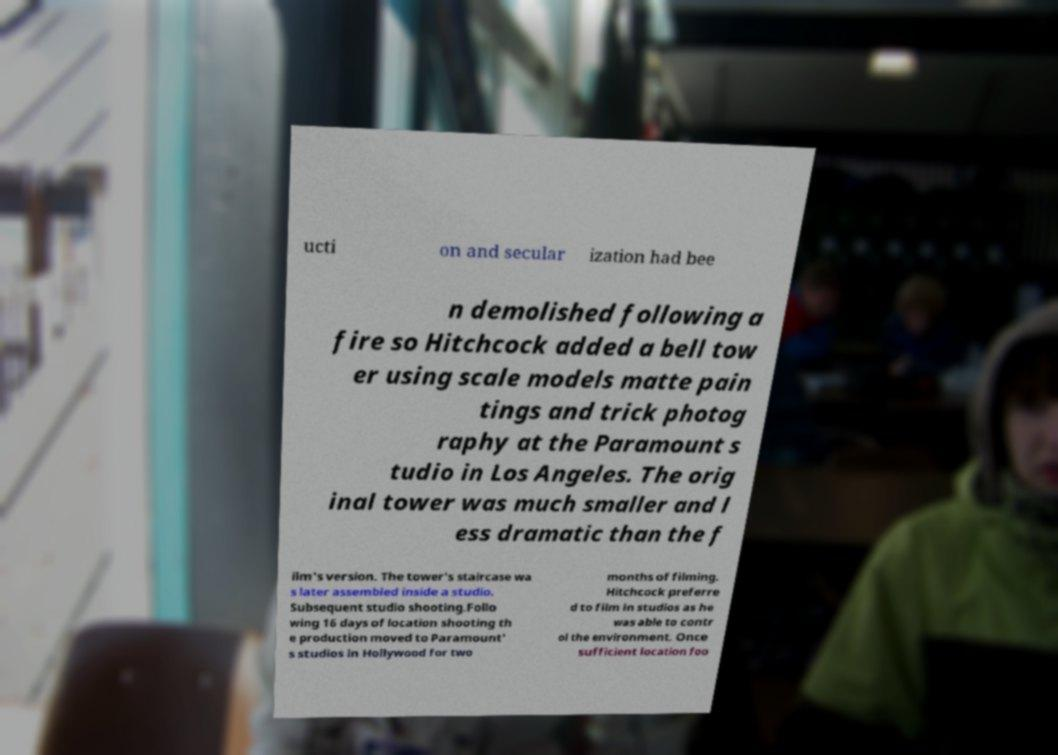Could you assist in decoding the text presented in this image and type it out clearly? ucti on and secular ization had bee n demolished following a fire so Hitchcock added a bell tow er using scale models matte pain tings and trick photog raphy at the Paramount s tudio in Los Angeles. The orig inal tower was much smaller and l ess dramatic than the f ilm's version. The tower's staircase wa s later assembled inside a studio. Subsequent studio shooting.Follo wing 16 days of location shooting th e production moved to Paramount' s studios in Hollywood for two months of filming. Hitchcock preferre d to film in studios as he was able to contr ol the environment. Once sufficient location foo 